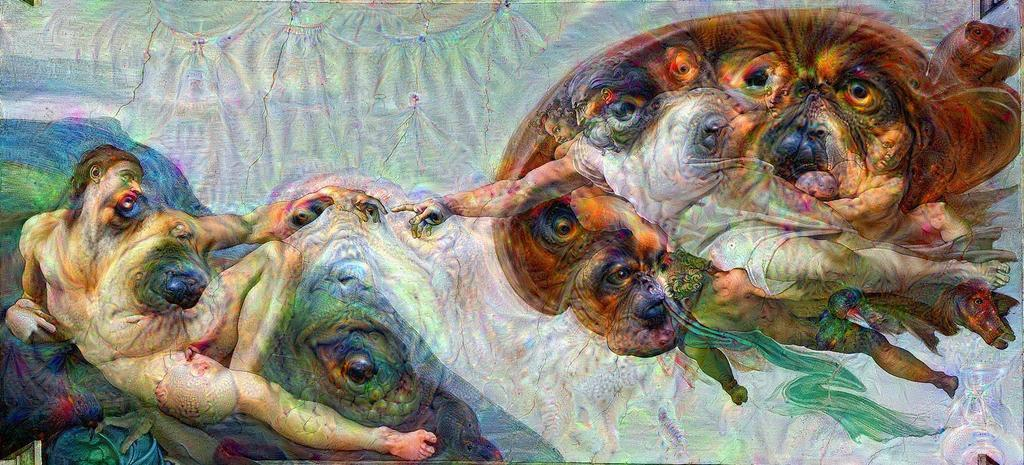What type of artwork is depicted in the image? The image is a painting. What animals are featured in the painting? There are dogs in the painting. Are there any human figures in the painting? Yes, there are people in the painting. What role does zinc play in the painting? There is no mention of zinc or any other specific materials used in the painting, so it cannot be determined what role, if any, zinc plays. 